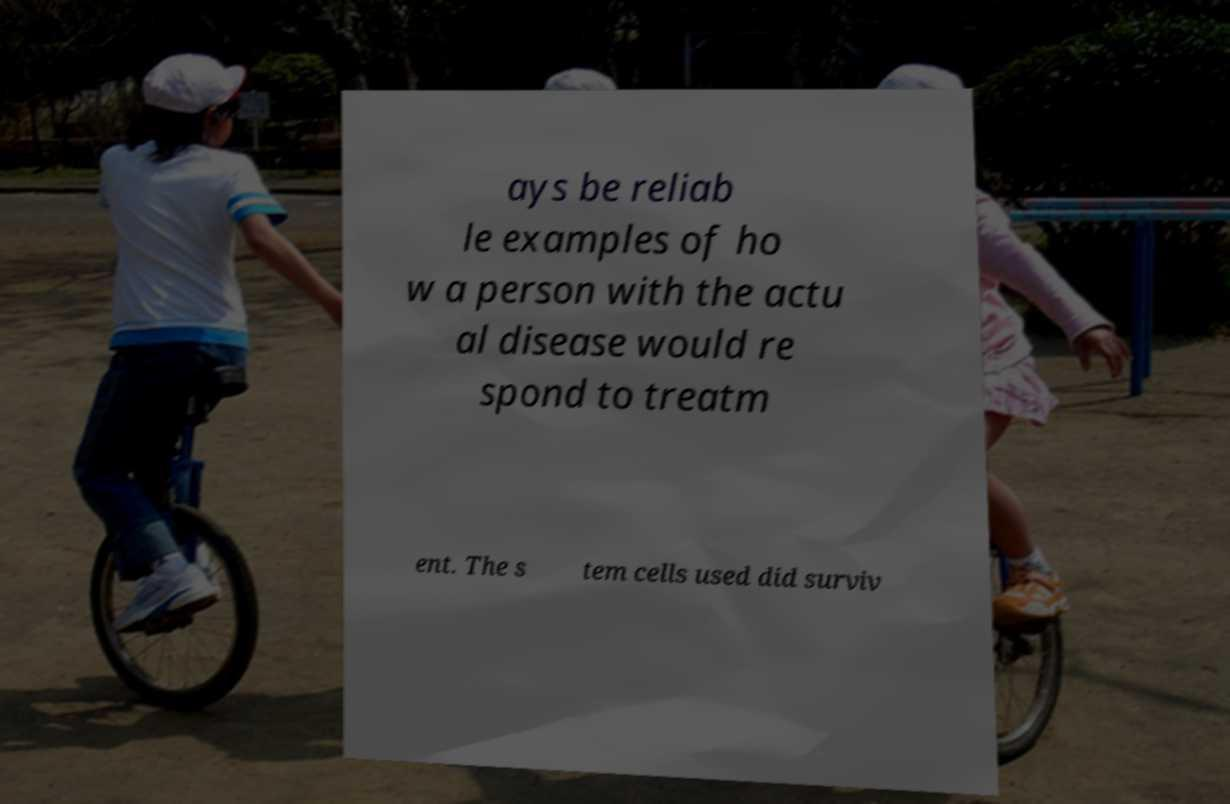Could you extract and type out the text from this image? ays be reliab le examples of ho w a person with the actu al disease would re spond to treatm ent. The s tem cells used did surviv 